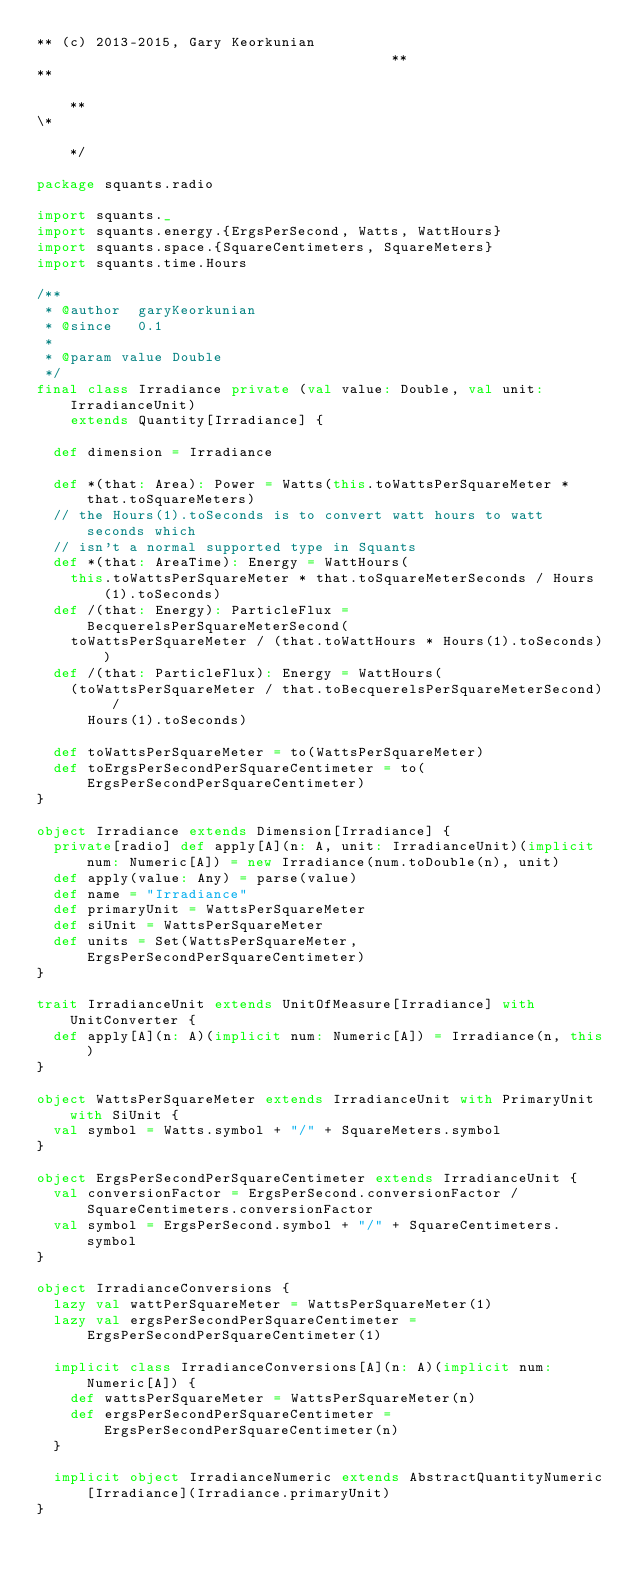<code> <loc_0><loc_0><loc_500><loc_500><_Scala_>** (c) 2013-2015, Gary Keorkunian                                       **
**                                                                      **
\*                                                                      */

package squants.radio

import squants._
import squants.energy.{ErgsPerSecond, Watts, WattHours}
import squants.space.{SquareCentimeters, SquareMeters}
import squants.time.Hours

/**
 * @author  garyKeorkunian
 * @since   0.1
 *
 * @param value Double
 */
final class Irradiance private (val value: Double, val unit: IrradianceUnit)
    extends Quantity[Irradiance] {

  def dimension = Irradiance

  def *(that: Area): Power = Watts(this.toWattsPerSquareMeter * that.toSquareMeters)
  // the Hours(1).toSeconds is to convert watt hours to watt seconds which 
  // isn't a normal supported type in Squants
  def *(that: AreaTime): Energy = WattHours(
    this.toWattsPerSquareMeter * that.toSquareMeterSeconds / Hours(1).toSeconds)
  def /(that: Energy): ParticleFlux = BecquerelsPerSquareMeterSecond(
    toWattsPerSquareMeter / (that.toWattHours * Hours(1).toSeconds))
  def /(that: ParticleFlux): Energy = WattHours(
    (toWattsPerSquareMeter / that.toBecquerelsPerSquareMeterSecond) / 
      Hours(1).toSeconds)

  def toWattsPerSquareMeter = to(WattsPerSquareMeter)
  def toErgsPerSecondPerSquareCentimeter = to(ErgsPerSecondPerSquareCentimeter)
}

object Irradiance extends Dimension[Irradiance] {
  private[radio] def apply[A](n: A, unit: IrradianceUnit)(implicit num: Numeric[A]) = new Irradiance(num.toDouble(n), unit)
  def apply(value: Any) = parse(value)
  def name = "Irradiance"
  def primaryUnit = WattsPerSquareMeter
  def siUnit = WattsPerSquareMeter
  def units = Set(WattsPerSquareMeter, ErgsPerSecondPerSquareCentimeter)
}

trait IrradianceUnit extends UnitOfMeasure[Irradiance] with UnitConverter {
  def apply[A](n: A)(implicit num: Numeric[A]) = Irradiance(n, this)
}

object WattsPerSquareMeter extends IrradianceUnit with PrimaryUnit with SiUnit {
  val symbol = Watts.symbol + "/" + SquareMeters.symbol
}

object ErgsPerSecondPerSquareCentimeter extends IrradianceUnit {
  val conversionFactor = ErgsPerSecond.conversionFactor / SquareCentimeters.conversionFactor
  val symbol = ErgsPerSecond.symbol + "/" + SquareCentimeters.symbol
}

object IrradianceConversions {
  lazy val wattPerSquareMeter = WattsPerSquareMeter(1)
  lazy val ergsPerSecondPerSquareCentimeter = ErgsPerSecondPerSquareCentimeter(1)

  implicit class IrradianceConversions[A](n: A)(implicit num: Numeric[A]) {
    def wattsPerSquareMeter = WattsPerSquareMeter(n)
    def ergsPerSecondPerSquareCentimeter = ErgsPerSecondPerSquareCentimeter(n)
  }

  implicit object IrradianceNumeric extends AbstractQuantityNumeric[Irradiance](Irradiance.primaryUnit)
}
</code> 